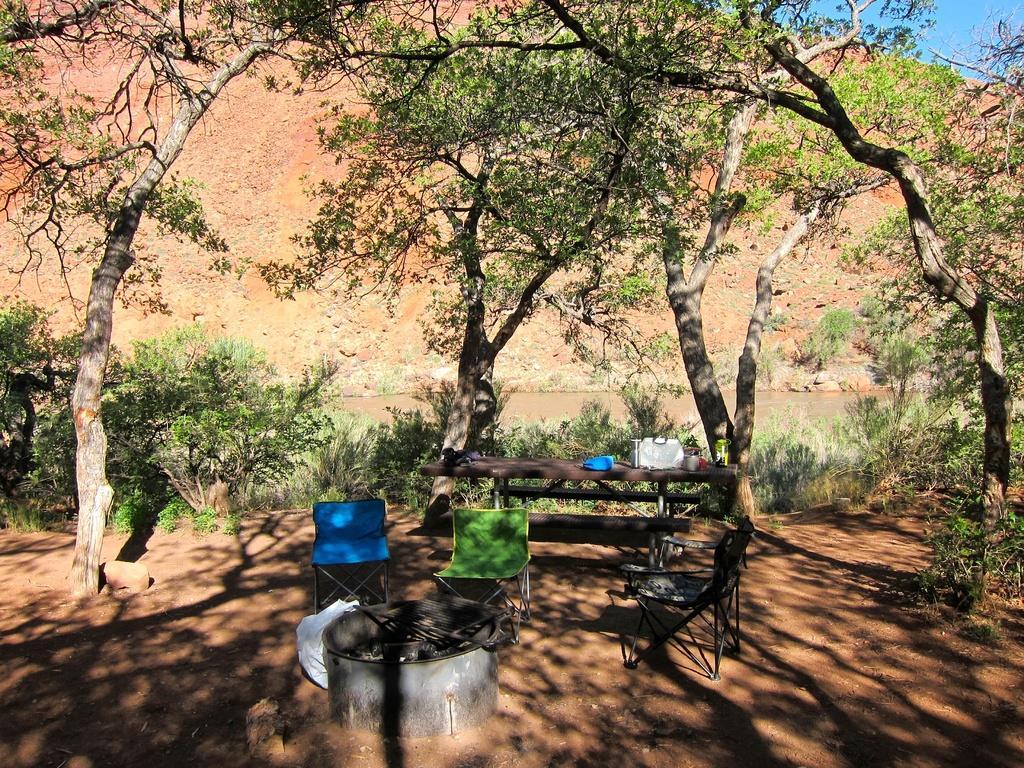How would you summarize this image in a sentence or two? In this image there are chairs. There is a fire pit. There is a table. On top of it there are few objects. In the center of the image there is water. In the background of the image there are trees, mountains and sky. 